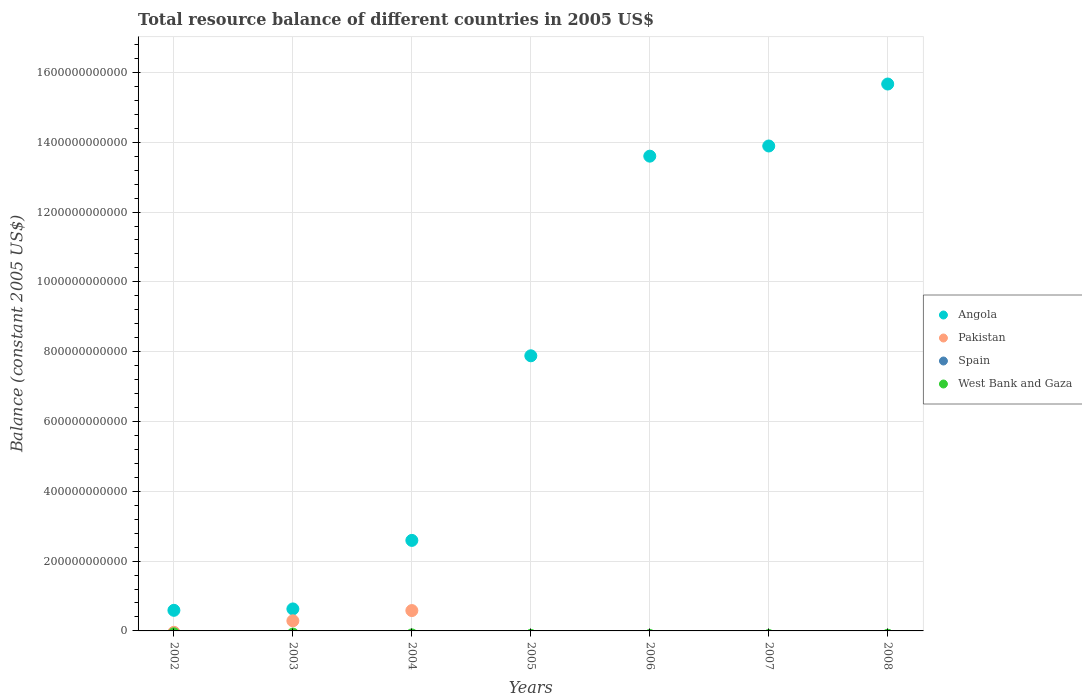What is the total resource balance in West Bank and Gaza in 2005?
Provide a succinct answer. 0. Across all years, what is the maximum total resource balance in Angola?
Make the answer very short. 1.57e+12. What is the total total resource balance in Spain in the graph?
Your answer should be very brief. 0. What is the difference between the total resource balance in Angola in 2003 and that in 2004?
Offer a terse response. -1.96e+11. What is the average total resource balance in Angola per year?
Keep it short and to the point. 7.84e+11. What is the ratio of the total resource balance in Angola in 2004 to that in 2005?
Make the answer very short. 0.33. What is the difference between the highest and the lowest total resource balance in Angola?
Keep it short and to the point. 1.51e+12. In how many years, is the total resource balance in West Bank and Gaza greater than the average total resource balance in West Bank and Gaza taken over all years?
Make the answer very short. 0. Is it the case that in every year, the sum of the total resource balance in Spain and total resource balance in Pakistan  is greater than the sum of total resource balance in West Bank and Gaza and total resource balance in Angola?
Offer a very short reply. No. Is it the case that in every year, the sum of the total resource balance in Angola and total resource balance in Pakistan  is greater than the total resource balance in West Bank and Gaza?
Your response must be concise. Yes. Does the total resource balance in Angola monotonically increase over the years?
Provide a succinct answer. Yes. Is the total resource balance in Pakistan strictly less than the total resource balance in West Bank and Gaza over the years?
Your answer should be compact. No. How many dotlines are there?
Provide a succinct answer. 2. How many years are there in the graph?
Provide a succinct answer. 7. What is the difference between two consecutive major ticks on the Y-axis?
Offer a terse response. 2.00e+11. Does the graph contain grids?
Offer a terse response. Yes. How many legend labels are there?
Give a very brief answer. 4. How are the legend labels stacked?
Your answer should be compact. Vertical. What is the title of the graph?
Ensure brevity in your answer.  Total resource balance of different countries in 2005 US$. Does "Senegal" appear as one of the legend labels in the graph?
Your answer should be compact. No. What is the label or title of the X-axis?
Give a very brief answer. Years. What is the label or title of the Y-axis?
Ensure brevity in your answer.  Balance (constant 2005 US$). What is the Balance (constant 2005 US$) of Angola in 2002?
Offer a very short reply. 5.90e+1. What is the Balance (constant 2005 US$) of Angola in 2003?
Make the answer very short. 6.30e+1. What is the Balance (constant 2005 US$) of Pakistan in 2003?
Offer a very short reply. 2.89e+1. What is the Balance (constant 2005 US$) of Angola in 2004?
Your answer should be compact. 2.59e+11. What is the Balance (constant 2005 US$) in Pakistan in 2004?
Offer a very short reply. 5.83e+1. What is the Balance (constant 2005 US$) in Spain in 2004?
Give a very brief answer. 0. What is the Balance (constant 2005 US$) of West Bank and Gaza in 2004?
Offer a very short reply. 0. What is the Balance (constant 2005 US$) of Angola in 2005?
Provide a succinct answer. 7.88e+11. What is the Balance (constant 2005 US$) of Angola in 2006?
Provide a short and direct response. 1.36e+12. What is the Balance (constant 2005 US$) in Pakistan in 2006?
Keep it short and to the point. 0. What is the Balance (constant 2005 US$) in Angola in 2007?
Your response must be concise. 1.39e+12. What is the Balance (constant 2005 US$) in Angola in 2008?
Your response must be concise. 1.57e+12. What is the Balance (constant 2005 US$) of Pakistan in 2008?
Keep it short and to the point. 0. What is the Balance (constant 2005 US$) in West Bank and Gaza in 2008?
Offer a very short reply. 0. Across all years, what is the maximum Balance (constant 2005 US$) of Angola?
Offer a very short reply. 1.57e+12. Across all years, what is the maximum Balance (constant 2005 US$) in Pakistan?
Provide a short and direct response. 5.83e+1. Across all years, what is the minimum Balance (constant 2005 US$) of Angola?
Offer a very short reply. 5.90e+1. What is the total Balance (constant 2005 US$) of Angola in the graph?
Your answer should be compact. 5.49e+12. What is the total Balance (constant 2005 US$) of Pakistan in the graph?
Provide a short and direct response. 8.72e+1. What is the difference between the Balance (constant 2005 US$) in Angola in 2002 and that in 2003?
Offer a very short reply. -4.00e+09. What is the difference between the Balance (constant 2005 US$) in Angola in 2002 and that in 2004?
Ensure brevity in your answer.  -2.00e+11. What is the difference between the Balance (constant 2005 US$) in Angola in 2002 and that in 2005?
Your answer should be compact. -7.29e+11. What is the difference between the Balance (constant 2005 US$) in Angola in 2002 and that in 2006?
Offer a terse response. -1.30e+12. What is the difference between the Balance (constant 2005 US$) in Angola in 2002 and that in 2007?
Your answer should be very brief. -1.33e+12. What is the difference between the Balance (constant 2005 US$) in Angola in 2002 and that in 2008?
Your answer should be compact. -1.51e+12. What is the difference between the Balance (constant 2005 US$) of Angola in 2003 and that in 2004?
Ensure brevity in your answer.  -1.96e+11. What is the difference between the Balance (constant 2005 US$) of Pakistan in 2003 and that in 2004?
Give a very brief answer. -2.94e+1. What is the difference between the Balance (constant 2005 US$) in Angola in 2003 and that in 2005?
Provide a short and direct response. -7.25e+11. What is the difference between the Balance (constant 2005 US$) in Angola in 2003 and that in 2006?
Keep it short and to the point. -1.30e+12. What is the difference between the Balance (constant 2005 US$) of Angola in 2003 and that in 2007?
Make the answer very short. -1.33e+12. What is the difference between the Balance (constant 2005 US$) of Angola in 2003 and that in 2008?
Make the answer very short. -1.50e+12. What is the difference between the Balance (constant 2005 US$) of Angola in 2004 and that in 2005?
Provide a short and direct response. -5.29e+11. What is the difference between the Balance (constant 2005 US$) of Angola in 2004 and that in 2006?
Provide a succinct answer. -1.10e+12. What is the difference between the Balance (constant 2005 US$) in Angola in 2004 and that in 2007?
Give a very brief answer. -1.13e+12. What is the difference between the Balance (constant 2005 US$) in Angola in 2004 and that in 2008?
Your answer should be very brief. -1.31e+12. What is the difference between the Balance (constant 2005 US$) of Angola in 2005 and that in 2006?
Make the answer very short. -5.72e+11. What is the difference between the Balance (constant 2005 US$) in Angola in 2005 and that in 2007?
Offer a terse response. -6.01e+11. What is the difference between the Balance (constant 2005 US$) of Angola in 2005 and that in 2008?
Your answer should be compact. -7.79e+11. What is the difference between the Balance (constant 2005 US$) in Angola in 2006 and that in 2007?
Ensure brevity in your answer.  -2.91e+1. What is the difference between the Balance (constant 2005 US$) of Angola in 2006 and that in 2008?
Provide a succinct answer. -2.07e+11. What is the difference between the Balance (constant 2005 US$) of Angola in 2007 and that in 2008?
Provide a short and direct response. -1.78e+11. What is the difference between the Balance (constant 2005 US$) of Angola in 2002 and the Balance (constant 2005 US$) of Pakistan in 2003?
Ensure brevity in your answer.  3.01e+1. What is the difference between the Balance (constant 2005 US$) in Angola in 2002 and the Balance (constant 2005 US$) in Pakistan in 2004?
Keep it short and to the point. 7.03e+08. What is the difference between the Balance (constant 2005 US$) of Angola in 2003 and the Balance (constant 2005 US$) of Pakistan in 2004?
Your answer should be very brief. 4.71e+09. What is the average Balance (constant 2005 US$) in Angola per year?
Make the answer very short. 7.84e+11. What is the average Balance (constant 2005 US$) of Pakistan per year?
Keep it short and to the point. 1.25e+1. What is the average Balance (constant 2005 US$) of West Bank and Gaza per year?
Your answer should be compact. 0. In the year 2003, what is the difference between the Balance (constant 2005 US$) in Angola and Balance (constant 2005 US$) in Pakistan?
Make the answer very short. 3.41e+1. In the year 2004, what is the difference between the Balance (constant 2005 US$) of Angola and Balance (constant 2005 US$) of Pakistan?
Provide a short and direct response. 2.01e+11. What is the ratio of the Balance (constant 2005 US$) of Angola in 2002 to that in 2003?
Offer a terse response. 0.94. What is the ratio of the Balance (constant 2005 US$) in Angola in 2002 to that in 2004?
Give a very brief answer. 0.23. What is the ratio of the Balance (constant 2005 US$) of Angola in 2002 to that in 2005?
Your answer should be compact. 0.07. What is the ratio of the Balance (constant 2005 US$) in Angola in 2002 to that in 2006?
Offer a terse response. 0.04. What is the ratio of the Balance (constant 2005 US$) of Angola in 2002 to that in 2007?
Offer a very short reply. 0.04. What is the ratio of the Balance (constant 2005 US$) of Angola in 2002 to that in 2008?
Provide a succinct answer. 0.04. What is the ratio of the Balance (constant 2005 US$) in Angola in 2003 to that in 2004?
Your response must be concise. 0.24. What is the ratio of the Balance (constant 2005 US$) in Pakistan in 2003 to that in 2004?
Offer a very short reply. 0.5. What is the ratio of the Balance (constant 2005 US$) of Angola in 2003 to that in 2005?
Make the answer very short. 0.08. What is the ratio of the Balance (constant 2005 US$) in Angola in 2003 to that in 2006?
Keep it short and to the point. 0.05. What is the ratio of the Balance (constant 2005 US$) of Angola in 2003 to that in 2007?
Keep it short and to the point. 0.05. What is the ratio of the Balance (constant 2005 US$) in Angola in 2003 to that in 2008?
Ensure brevity in your answer.  0.04. What is the ratio of the Balance (constant 2005 US$) in Angola in 2004 to that in 2005?
Your answer should be very brief. 0.33. What is the ratio of the Balance (constant 2005 US$) of Angola in 2004 to that in 2006?
Keep it short and to the point. 0.19. What is the ratio of the Balance (constant 2005 US$) of Angola in 2004 to that in 2007?
Provide a succinct answer. 0.19. What is the ratio of the Balance (constant 2005 US$) of Angola in 2004 to that in 2008?
Your response must be concise. 0.17. What is the ratio of the Balance (constant 2005 US$) in Angola in 2005 to that in 2006?
Your answer should be very brief. 0.58. What is the ratio of the Balance (constant 2005 US$) of Angola in 2005 to that in 2007?
Your answer should be compact. 0.57. What is the ratio of the Balance (constant 2005 US$) of Angola in 2005 to that in 2008?
Provide a succinct answer. 0.5. What is the ratio of the Balance (constant 2005 US$) of Angola in 2006 to that in 2008?
Your response must be concise. 0.87. What is the ratio of the Balance (constant 2005 US$) in Angola in 2007 to that in 2008?
Your response must be concise. 0.89. What is the difference between the highest and the second highest Balance (constant 2005 US$) of Angola?
Offer a very short reply. 1.78e+11. What is the difference between the highest and the lowest Balance (constant 2005 US$) of Angola?
Keep it short and to the point. 1.51e+12. What is the difference between the highest and the lowest Balance (constant 2005 US$) of Pakistan?
Your answer should be compact. 5.83e+1. 